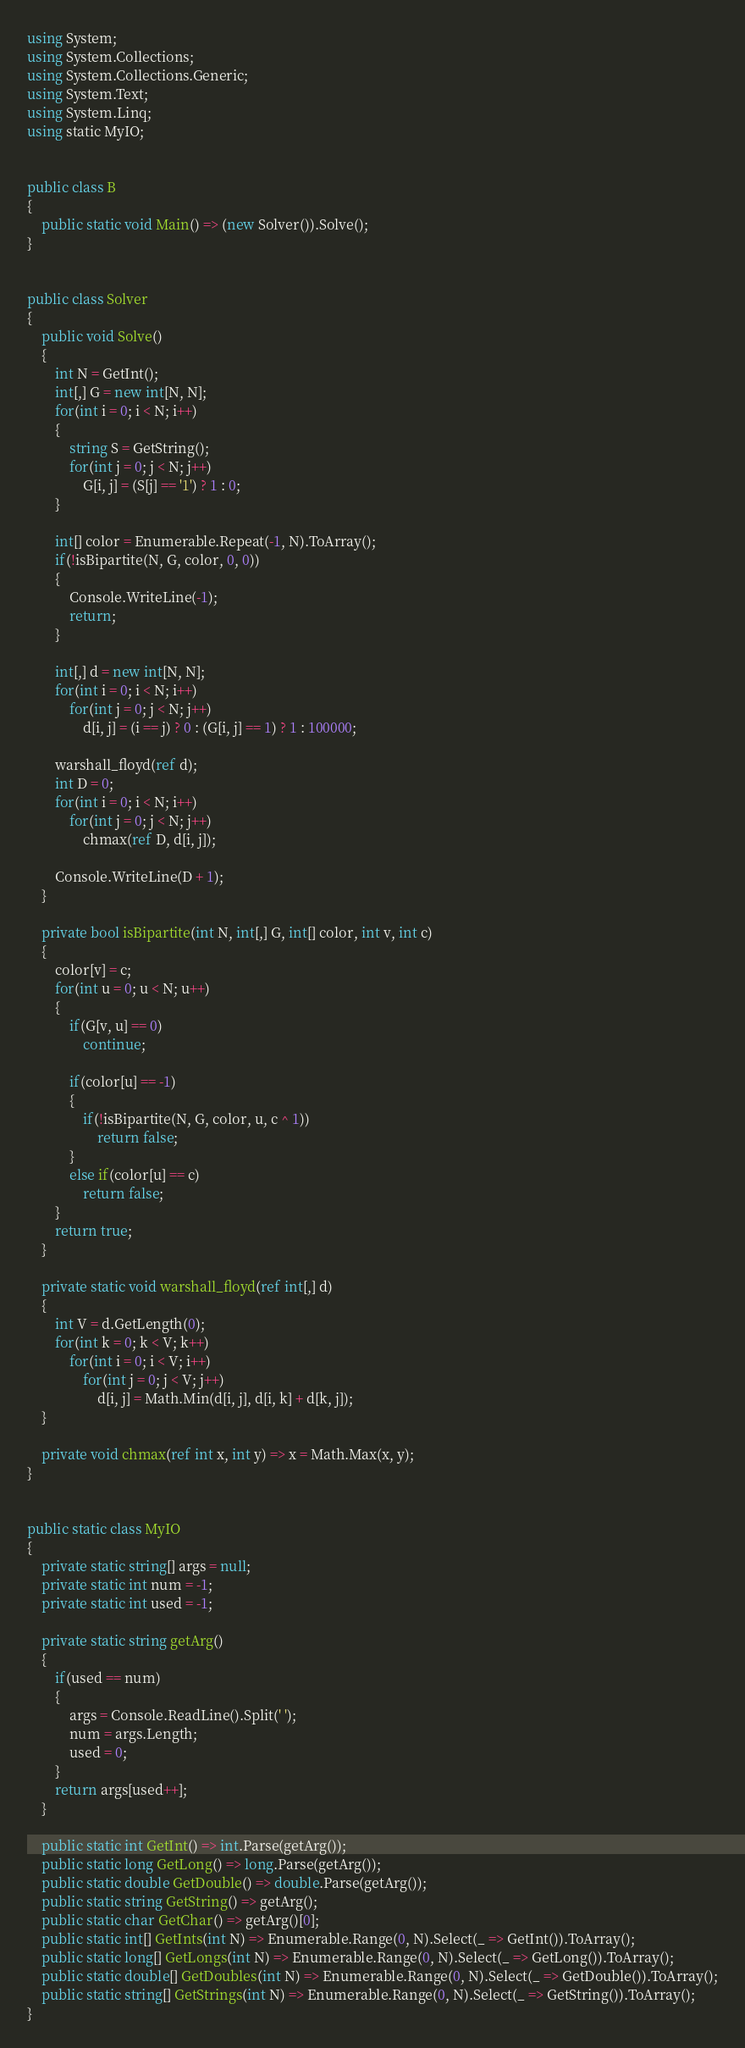Convert code to text. <code><loc_0><loc_0><loc_500><loc_500><_C#_>using System;
using System.Collections;
using System.Collections.Generic;
using System.Text;
using System.Linq;
using static MyIO;


public class B
{
	public static void Main() => (new Solver()).Solve();
}


public class Solver
{
	public void Solve()
	{
		int N = GetInt();
		int[,] G = new int[N, N];
		for(int i = 0; i < N; i++)
		{
			string S = GetString();
			for(int j = 0; j < N; j++)
				G[i, j] = (S[j] == '1') ? 1 : 0;
		}

		int[] color = Enumerable.Repeat(-1, N).ToArray();
		if(!isBipartite(N, G, color, 0, 0))
		{
			Console.WriteLine(-1);
			return;
		}

		int[,] d = new int[N, N];
		for(int i = 0; i < N; i++)
			for(int j = 0; j < N; j++)
				d[i, j] = (i == j) ? 0 : (G[i, j] == 1) ? 1 : 100000;

		warshall_floyd(ref d);
		int D = 0;
		for(int i = 0; i < N; i++)
			for(int j = 0; j < N; j++)
				chmax(ref D, d[i, j]);

		Console.WriteLine(D + 1);
	}

	private bool isBipartite(int N, int[,] G, int[] color, int v, int c)
	{
		color[v] = c;
		for(int u = 0; u < N; u++)
		{
			if(G[v, u] == 0)
				continue;

			if(color[u] == -1)
			{
				if(!isBipartite(N, G, color, u, c ^ 1))
					return false;
			}
			else if(color[u] == c)
				return false;			
		}
		return true;
	}

	private static void warshall_floyd(ref int[,] d)
	{
		int V = d.GetLength(0);
		for(int k = 0; k < V; k++)
			for(int i = 0; i < V; i++)
				for(int j = 0; j < V; j++)
					d[i, j] = Math.Min(d[i, j], d[i, k] + d[k, j]);
	}

	private void chmax(ref int x, int y) => x = Math.Max(x, y);
}


public static class MyIO
{
	private static string[] args = null;
	private static int num = -1;
	private static int used = -1;

	private static string getArg()
	{
		if(used == num)
		{
			args = Console.ReadLine().Split(' ');
			num = args.Length;
			used = 0;
		}
		return args[used++];
	}

	public static int GetInt() => int.Parse(getArg());
	public static long GetLong() => long.Parse(getArg());
	public static double GetDouble() => double.Parse(getArg());
	public static string GetString() => getArg();
	public static char GetChar() => getArg()[0];
	public static int[] GetInts(int N) => Enumerable.Range(0, N).Select(_ => GetInt()).ToArray();
	public static long[] GetLongs(int N) => Enumerable.Range(0, N).Select(_ => GetLong()).ToArray();
	public static double[] GetDoubles(int N) => Enumerable.Range(0, N).Select(_ => GetDouble()).ToArray();
	public static string[] GetStrings(int N) => Enumerable.Range(0, N).Select(_ => GetString()).ToArray();
}
</code> 